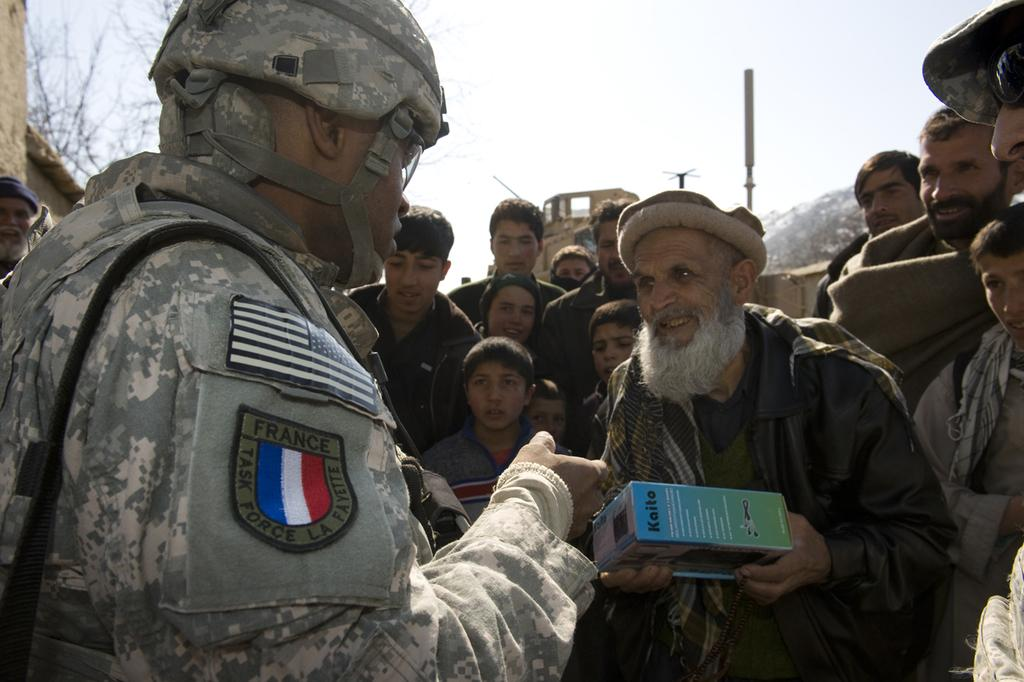How many people are in the group in the image? There is a group of people in the image, but the exact number is not specified. What is the emotional state of some people in the group? Some people in the group are smiling. What is the old person holding in the image? The old person is holding a box. What can be seen in the background of the image? There are trees, poles, and the sky visible in the background of the image. What type of patch is being sewn onto the old person's clothing in the image? There is no patch visible on the old person's clothing in the image. What is the base used for in the image? There is no base present in the image. 